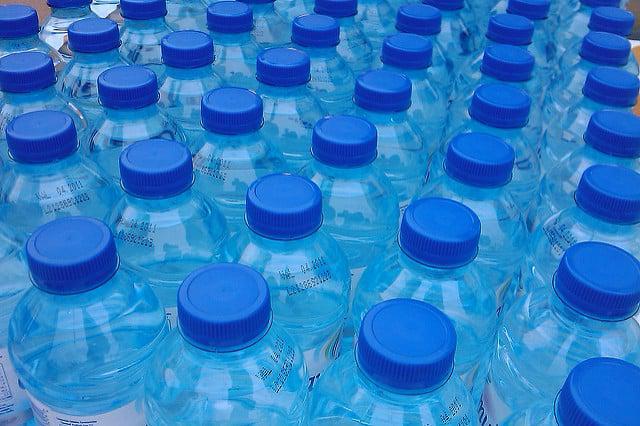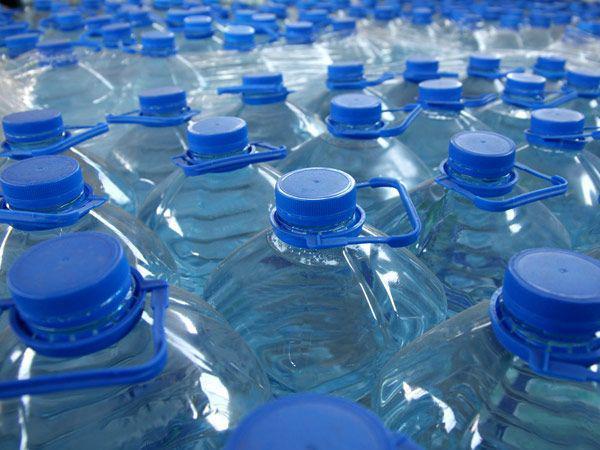The first image is the image on the left, the second image is the image on the right. Examine the images to the left and right. Is the description "All bottles of water have blue plastic caps." accurate? Answer yes or no. Yes. 